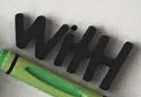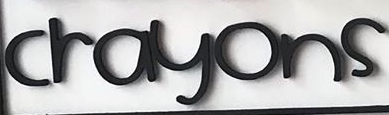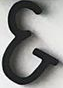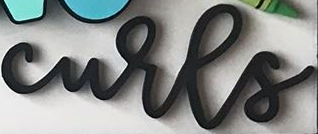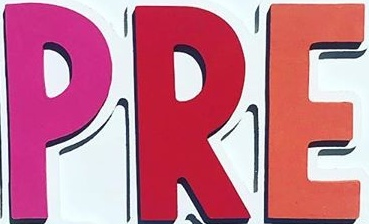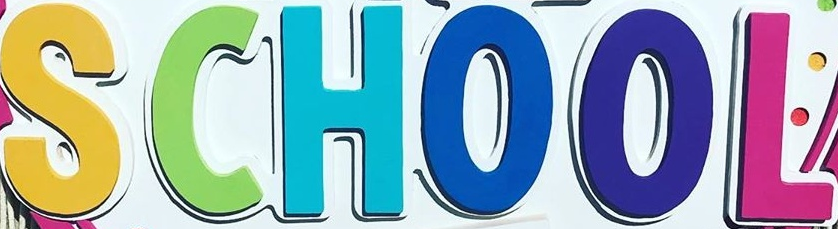What words can you see in these images in sequence, separated by a semicolon? WitH; crayons; &; curls; PRE; SCHOOL 